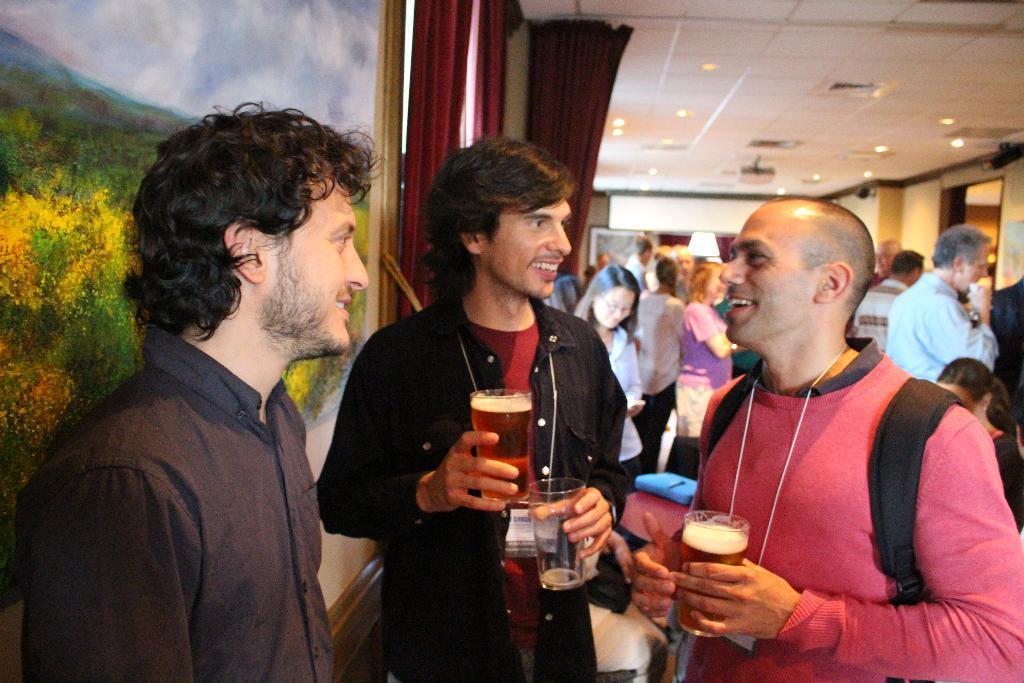How would you summarize this image in a sentence or two? In this image we can see people standing on the floor and some are holding beverage glasses in their hands. In the background we can see wall hangings on the walls, curtains and electric lights to the roof. 